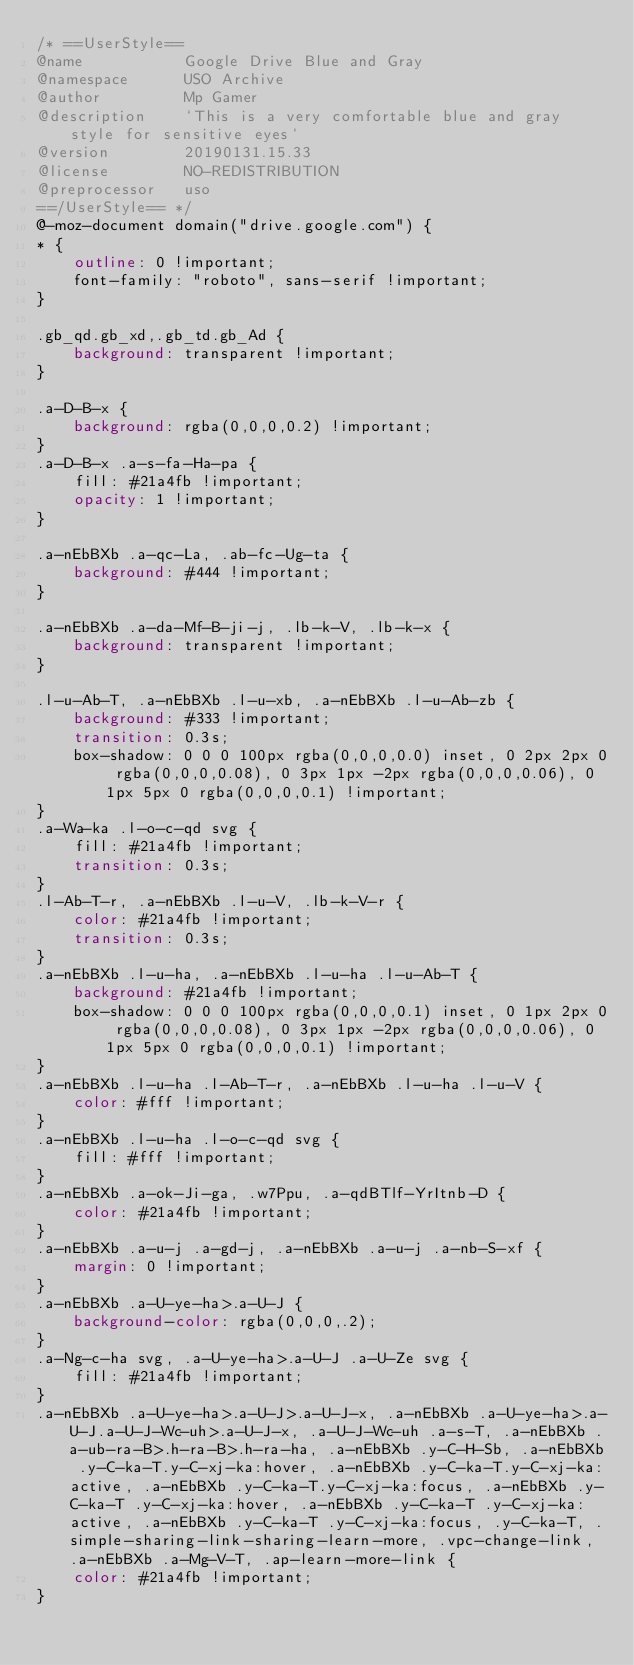Convert code to text. <code><loc_0><loc_0><loc_500><loc_500><_CSS_>/* ==UserStyle==
@name           Google Drive Blue and Gray
@namespace      USO Archive
@author         Mp Gamer
@description    `This is a very comfortable blue and gray style for sensitive eyes`
@version        20190131.15.33
@license        NO-REDISTRIBUTION
@preprocessor   uso
==/UserStyle== */
@-moz-document domain("drive.google.com") {
* {
    outline: 0 !important;
    font-family: "roboto", sans-serif !important;
}

.gb_qd.gb_xd,.gb_td.gb_Ad {
    background: transparent !important;
}

.a-D-B-x {
    background: rgba(0,0,0,0.2) !important;
}
.a-D-B-x .a-s-fa-Ha-pa {
    fill: #21a4fb !important;
    opacity: 1 !important;
}

.a-nEbBXb .a-qc-La, .ab-fc-Ug-ta {
    background: #444 !important;
}

.a-nEbBXb .a-da-Mf-B-ji-j, .lb-k-V, .lb-k-x {
    background: transparent !important;
}

.l-u-Ab-T, .a-nEbBXb .l-u-xb, .a-nEbBXb .l-u-Ab-zb {
    background: #333 !important;
    transition: 0.3s;
    box-shadow: 0 0 0 100px rgba(0,0,0,0.0) inset, 0 2px 2px 0 rgba(0,0,0,0.08), 0 3px 1px -2px rgba(0,0,0,0.06), 0 1px 5px 0 rgba(0,0,0,0.1) !important;
}
.a-Wa-ka .l-o-c-qd svg {
    fill: #21a4fb !important;
    transition: 0.3s;
}
.l-Ab-T-r, .a-nEbBXb .l-u-V, .lb-k-V-r {
    color: #21a4fb !important;
    transition: 0.3s;
}
.a-nEbBXb .l-u-ha, .a-nEbBXb .l-u-ha .l-u-Ab-T {
    background: #21a4fb !important;
    box-shadow: 0 0 0 100px rgba(0,0,0,0.1) inset, 0 1px 2px 0 rgba(0,0,0,0.08), 0 3px 1px -2px rgba(0,0,0,0.06), 0 1px 5px 0 rgba(0,0,0,0.1) !important;
}
.a-nEbBXb .l-u-ha .l-Ab-T-r, .a-nEbBXb .l-u-ha .l-u-V {
    color: #fff !important;
}
.a-nEbBXb .l-u-ha .l-o-c-qd svg {
    fill: #fff !important;
}
.a-nEbBXb .a-ok-Ji-ga, .w7Ppu, .a-qdBTlf-YrItnb-D {
    color: #21a4fb !important;
}
.a-nEbBXb .a-u-j .a-gd-j, .a-nEbBXb .a-u-j .a-nb-S-xf {
    margin: 0 !important;
}
.a-nEbBXb .a-U-ye-ha>.a-U-J {
    background-color: rgba(0,0,0,.2);
}
.a-Ng-c-ha svg, .a-U-ye-ha>.a-U-J .a-U-Ze svg {
    fill: #21a4fb !important;
}
.a-nEbBXb .a-U-ye-ha>.a-U-J>.a-U-J-x, .a-nEbBXb .a-U-ye-ha>.a-U-J.a-U-J-Wc-uh>.a-U-J-x, .a-U-J-Wc-uh .a-s-T, .a-nEbBXb .a-ub-ra-B>.h-ra-B>.h-ra-ha, .a-nEbBXb .y-C-H-Sb, .a-nEbBXb .y-C-ka-T.y-C-xj-ka:hover, .a-nEbBXb .y-C-ka-T.y-C-xj-ka:active, .a-nEbBXb .y-C-ka-T.y-C-xj-ka:focus, .a-nEbBXb .y-C-ka-T .y-C-xj-ka:hover, .a-nEbBXb .y-C-ka-T .y-C-xj-ka:active, .a-nEbBXb .y-C-ka-T .y-C-xj-ka:focus, .y-C-ka-T, .simple-sharing-link-sharing-learn-more, .vpc-change-link, .a-nEbBXb .a-Mg-V-T, .ap-learn-more-link {
    color: #21a4fb !important;
}</code> 